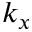Convert formula to latex. <formula><loc_0><loc_0><loc_500><loc_500>k _ { x }</formula> 